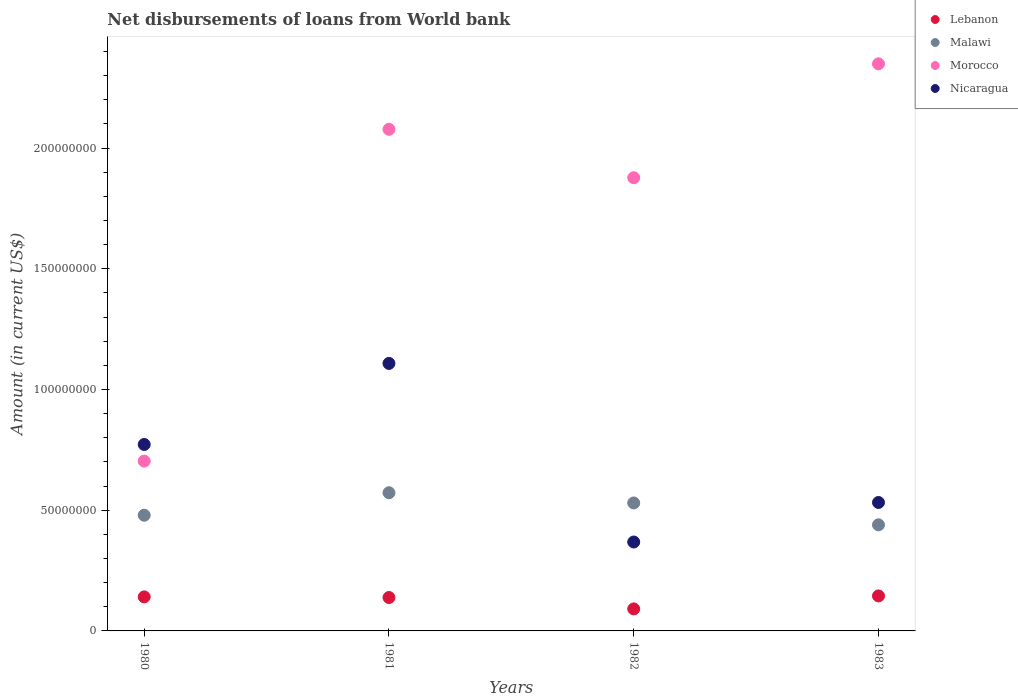How many different coloured dotlines are there?
Your response must be concise. 4. Is the number of dotlines equal to the number of legend labels?
Offer a terse response. Yes. What is the amount of loan disbursed from World Bank in Morocco in 1982?
Ensure brevity in your answer.  1.88e+08. Across all years, what is the maximum amount of loan disbursed from World Bank in Nicaragua?
Your response must be concise. 1.11e+08. Across all years, what is the minimum amount of loan disbursed from World Bank in Nicaragua?
Provide a succinct answer. 3.68e+07. In which year was the amount of loan disbursed from World Bank in Lebanon minimum?
Offer a terse response. 1982. What is the total amount of loan disbursed from World Bank in Morocco in the graph?
Give a very brief answer. 7.01e+08. What is the difference between the amount of loan disbursed from World Bank in Nicaragua in 1980 and that in 1982?
Offer a very short reply. 4.04e+07. What is the difference between the amount of loan disbursed from World Bank in Nicaragua in 1980 and the amount of loan disbursed from World Bank in Lebanon in 1982?
Give a very brief answer. 6.81e+07. What is the average amount of loan disbursed from World Bank in Malawi per year?
Make the answer very short. 5.05e+07. In the year 1983, what is the difference between the amount of loan disbursed from World Bank in Nicaragua and amount of loan disbursed from World Bank in Morocco?
Provide a succinct answer. -1.82e+08. In how many years, is the amount of loan disbursed from World Bank in Lebanon greater than 10000000 US$?
Provide a short and direct response. 3. What is the ratio of the amount of loan disbursed from World Bank in Nicaragua in 1982 to that in 1983?
Offer a very short reply. 0.69. Is the amount of loan disbursed from World Bank in Malawi in 1980 less than that in 1983?
Make the answer very short. No. What is the difference between the highest and the second highest amount of loan disbursed from World Bank in Nicaragua?
Keep it short and to the point. 3.36e+07. What is the difference between the highest and the lowest amount of loan disbursed from World Bank in Malawi?
Your response must be concise. 1.33e+07. Is the sum of the amount of loan disbursed from World Bank in Nicaragua in 1981 and 1982 greater than the maximum amount of loan disbursed from World Bank in Morocco across all years?
Provide a succinct answer. No. Does the amount of loan disbursed from World Bank in Nicaragua monotonically increase over the years?
Your response must be concise. No. Is the amount of loan disbursed from World Bank in Malawi strictly less than the amount of loan disbursed from World Bank in Nicaragua over the years?
Ensure brevity in your answer.  No. How many years are there in the graph?
Make the answer very short. 4. What is the difference between two consecutive major ticks on the Y-axis?
Give a very brief answer. 5.00e+07. Does the graph contain grids?
Your response must be concise. No. How are the legend labels stacked?
Make the answer very short. Vertical. What is the title of the graph?
Give a very brief answer. Net disbursements of loans from World bank. Does "South Africa" appear as one of the legend labels in the graph?
Give a very brief answer. No. What is the Amount (in current US$) of Lebanon in 1980?
Your answer should be compact. 1.41e+07. What is the Amount (in current US$) of Malawi in 1980?
Provide a short and direct response. 4.79e+07. What is the Amount (in current US$) of Morocco in 1980?
Make the answer very short. 7.03e+07. What is the Amount (in current US$) of Nicaragua in 1980?
Ensure brevity in your answer.  7.72e+07. What is the Amount (in current US$) of Lebanon in 1981?
Give a very brief answer. 1.38e+07. What is the Amount (in current US$) of Malawi in 1981?
Provide a short and direct response. 5.72e+07. What is the Amount (in current US$) of Morocco in 1981?
Provide a short and direct response. 2.08e+08. What is the Amount (in current US$) of Nicaragua in 1981?
Your answer should be compact. 1.11e+08. What is the Amount (in current US$) in Lebanon in 1982?
Your response must be concise. 9.12e+06. What is the Amount (in current US$) of Malawi in 1982?
Offer a very short reply. 5.30e+07. What is the Amount (in current US$) of Morocco in 1982?
Your response must be concise. 1.88e+08. What is the Amount (in current US$) in Nicaragua in 1982?
Keep it short and to the point. 3.68e+07. What is the Amount (in current US$) in Lebanon in 1983?
Provide a succinct answer. 1.45e+07. What is the Amount (in current US$) of Malawi in 1983?
Offer a very short reply. 4.40e+07. What is the Amount (in current US$) of Morocco in 1983?
Your response must be concise. 2.35e+08. What is the Amount (in current US$) of Nicaragua in 1983?
Make the answer very short. 5.32e+07. Across all years, what is the maximum Amount (in current US$) of Lebanon?
Your answer should be very brief. 1.45e+07. Across all years, what is the maximum Amount (in current US$) in Malawi?
Provide a short and direct response. 5.72e+07. Across all years, what is the maximum Amount (in current US$) of Morocco?
Your answer should be compact. 2.35e+08. Across all years, what is the maximum Amount (in current US$) in Nicaragua?
Your answer should be very brief. 1.11e+08. Across all years, what is the minimum Amount (in current US$) in Lebanon?
Your answer should be very brief. 9.12e+06. Across all years, what is the minimum Amount (in current US$) of Malawi?
Your answer should be very brief. 4.40e+07. Across all years, what is the minimum Amount (in current US$) of Morocco?
Your answer should be compact. 7.03e+07. Across all years, what is the minimum Amount (in current US$) of Nicaragua?
Provide a short and direct response. 3.68e+07. What is the total Amount (in current US$) in Lebanon in the graph?
Your answer should be compact. 5.16e+07. What is the total Amount (in current US$) of Malawi in the graph?
Provide a succinct answer. 2.02e+08. What is the total Amount (in current US$) of Morocco in the graph?
Provide a short and direct response. 7.01e+08. What is the total Amount (in current US$) in Nicaragua in the graph?
Ensure brevity in your answer.  2.78e+08. What is the difference between the Amount (in current US$) of Lebanon in 1980 and that in 1981?
Offer a terse response. 2.55e+05. What is the difference between the Amount (in current US$) in Malawi in 1980 and that in 1981?
Offer a very short reply. -9.32e+06. What is the difference between the Amount (in current US$) in Morocco in 1980 and that in 1981?
Offer a very short reply. -1.37e+08. What is the difference between the Amount (in current US$) in Nicaragua in 1980 and that in 1981?
Ensure brevity in your answer.  -3.36e+07. What is the difference between the Amount (in current US$) of Lebanon in 1980 and that in 1982?
Offer a very short reply. 4.98e+06. What is the difference between the Amount (in current US$) of Malawi in 1980 and that in 1982?
Give a very brief answer. -5.09e+06. What is the difference between the Amount (in current US$) in Morocco in 1980 and that in 1982?
Your answer should be very brief. -1.17e+08. What is the difference between the Amount (in current US$) of Nicaragua in 1980 and that in 1982?
Keep it short and to the point. 4.04e+07. What is the difference between the Amount (in current US$) of Lebanon in 1980 and that in 1983?
Keep it short and to the point. -4.09e+05. What is the difference between the Amount (in current US$) of Malawi in 1980 and that in 1983?
Give a very brief answer. 3.97e+06. What is the difference between the Amount (in current US$) in Morocco in 1980 and that in 1983?
Your answer should be very brief. -1.65e+08. What is the difference between the Amount (in current US$) of Nicaragua in 1980 and that in 1983?
Your answer should be compact. 2.40e+07. What is the difference between the Amount (in current US$) of Lebanon in 1981 and that in 1982?
Make the answer very short. 4.72e+06. What is the difference between the Amount (in current US$) in Malawi in 1981 and that in 1982?
Your answer should be compact. 4.23e+06. What is the difference between the Amount (in current US$) in Morocco in 1981 and that in 1982?
Your response must be concise. 2.01e+07. What is the difference between the Amount (in current US$) of Nicaragua in 1981 and that in 1982?
Provide a succinct answer. 7.40e+07. What is the difference between the Amount (in current US$) in Lebanon in 1981 and that in 1983?
Your answer should be compact. -6.64e+05. What is the difference between the Amount (in current US$) of Malawi in 1981 and that in 1983?
Your response must be concise. 1.33e+07. What is the difference between the Amount (in current US$) in Morocco in 1981 and that in 1983?
Offer a terse response. -2.71e+07. What is the difference between the Amount (in current US$) of Nicaragua in 1981 and that in 1983?
Offer a terse response. 5.76e+07. What is the difference between the Amount (in current US$) in Lebanon in 1982 and that in 1983?
Offer a very short reply. -5.38e+06. What is the difference between the Amount (in current US$) of Malawi in 1982 and that in 1983?
Offer a terse response. 9.06e+06. What is the difference between the Amount (in current US$) of Morocco in 1982 and that in 1983?
Provide a succinct answer. -4.72e+07. What is the difference between the Amount (in current US$) in Nicaragua in 1982 and that in 1983?
Ensure brevity in your answer.  -1.64e+07. What is the difference between the Amount (in current US$) of Lebanon in 1980 and the Amount (in current US$) of Malawi in 1981?
Provide a succinct answer. -4.31e+07. What is the difference between the Amount (in current US$) of Lebanon in 1980 and the Amount (in current US$) of Morocco in 1981?
Your answer should be compact. -1.94e+08. What is the difference between the Amount (in current US$) in Lebanon in 1980 and the Amount (in current US$) in Nicaragua in 1981?
Make the answer very short. -9.67e+07. What is the difference between the Amount (in current US$) of Malawi in 1980 and the Amount (in current US$) of Morocco in 1981?
Ensure brevity in your answer.  -1.60e+08. What is the difference between the Amount (in current US$) of Malawi in 1980 and the Amount (in current US$) of Nicaragua in 1981?
Offer a very short reply. -6.29e+07. What is the difference between the Amount (in current US$) of Morocco in 1980 and the Amount (in current US$) of Nicaragua in 1981?
Ensure brevity in your answer.  -4.05e+07. What is the difference between the Amount (in current US$) in Lebanon in 1980 and the Amount (in current US$) in Malawi in 1982?
Your answer should be very brief. -3.89e+07. What is the difference between the Amount (in current US$) in Lebanon in 1980 and the Amount (in current US$) in Morocco in 1982?
Keep it short and to the point. -1.74e+08. What is the difference between the Amount (in current US$) in Lebanon in 1980 and the Amount (in current US$) in Nicaragua in 1982?
Keep it short and to the point. -2.27e+07. What is the difference between the Amount (in current US$) in Malawi in 1980 and the Amount (in current US$) in Morocco in 1982?
Your answer should be compact. -1.40e+08. What is the difference between the Amount (in current US$) of Malawi in 1980 and the Amount (in current US$) of Nicaragua in 1982?
Make the answer very short. 1.11e+07. What is the difference between the Amount (in current US$) in Morocco in 1980 and the Amount (in current US$) in Nicaragua in 1982?
Offer a very short reply. 3.35e+07. What is the difference between the Amount (in current US$) of Lebanon in 1980 and the Amount (in current US$) of Malawi in 1983?
Ensure brevity in your answer.  -2.99e+07. What is the difference between the Amount (in current US$) in Lebanon in 1980 and the Amount (in current US$) in Morocco in 1983?
Provide a short and direct response. -2.21e+08. What is the difference between the Amount (in current US$) in Lebanon in 1980 and the Amount (in current US$) in Nicaragua in 1983?
Make the answer very short. -3.91e+07. What is the difference between the Amount (in current US$) in Malawi in 1980 and the Amount (in current US$) in Morocco in 1983?
Offer a terse response. -1.87e+08. What is the difference between the Amount (in current US$) of Malawi in 1980 and the Amount (in current US$) of Nicaragua in 1983?
Give a very brief answer. -5.28e+06. What is the difference between the Amount (in current US$) of Morocco in 1980 and the Amount (in current US$) of Nicaragua in 1983?
Provide a succinct answer. 1.71e+07. What is the difference between the Amount (in current US$) in Lebanon in 1981 and the Amount (in current US$) in Malawi in 1982?
Your answer should be compact. -3.92e+07. What is the difference between the Amount (in current US$) in Lebanon in 1981 and the Amount (in current US$) in Morocco in 1982?
Your answer should be compact. -1.74e+08. What is the difference between the Amount (in current US$) in Lebanon in 1981 and the Amount (in current US$) in Nicaragua in 1982?
Your answer should be compact. -2.30e+07. What is the difference between the Amount (in current US$) of Malawi in 1981 and the Amount (in current US$) of Morocco in 1982?
Make the answer very short. -1.30e+08. What is the difference between the Amount (in current US$) of Malawi in 1981 and the Amount (in current US$) of Nicaragua in 1982?
Keep it short and to the point. 2.04e+07. What is the difference between the Amount (in current US$) in Morocco in 1981 and the Amount (in current US$) in Nicaragua in 1982?
Provide a succinct answer. 1.71e+08. What is the difference between the Amount (in current US$) of Lebanon in 1981 and the Amount (in current US$) of Malawi in 1983?
Keep it short and to the point. -3.01e+07. What is the difference between the Amount (in current US$) of Lebanon in 1981 and the Amount (in current US$) of Morocco in 1983?
Provide a short and direct response. -2.21e+08. What is the difference between the Amount (in current US$) of Lebanon in 1981 and the Amount (in current US$) of Nicaragua in 1983?
Keep it short and to the point. -3.94e+07. What is the difference between the Amount (in current US$) in Malawi in 1981 and the Amount (in current US$) in Morocco in 1983?
Ensure brevity in your answer.  -1.78e+08. What is the difference between the Amount (in current US$) of Malawi in 1981 and the Amount (in current US$) of Nicaragua in 1983?
Your response must be concise. 4.04e+06. What is the difference between the Amount (in current US$) in Morocco in 1981 and the Amount (in current US$) in Nicaragua in 1983?
Your answer should be compact. 1.55e+08. What is the difference between the Amount (in current US$) in Lebanon in 1982 and the Amount (in current US$) in Malawi in 1983?
Keep it short and to the point. -3.48e+07. What is the difference between the Amount (in current US$) of Lebanon in 1982 and the Amount (in current US$) of Morocco in 1983?
Provide a succinct answer. -2.26e+08. What is the difference between the Amount (in current US$) of Lebanon in 1982 and the Amount (in current US$) of Nicaragua in 1983?
Give a very brief answer. -4.41e+07. What is the difference between the Amount (in current US$) of Malawi in 1982 and the Amount (in current US$) of Morocco in 1983?
Provide a short and direct response. -1.82e+08. What is the difference between the Amount (in current US$) in Morocco in 1982 and the Amount (in current US$) in Nicaragua in 1983?
Keep it short and to the point. 1.35e+08. What is the average Amount (in current US$) of Lebanon per year?
Offer a terse response. 1.29e+07. What is the average Amount (in current US$) of Malawi per year?
Your response must be concise. 5.05e+07. What is the average Amount (in current US$) of Morocco per year?
Provide a short and direct response. 1.75e+08. What is the average Amount (in current US$) in Nicaragua per year?
Provide a succinct answer. 6.95e+07. In the year 1980, what is the difference between the Amount (in current US$) of Lebanon and Amount (in current US$) of Malawi?
Your answer should be compact. -3.38e+07. In the year 1980, what is the difference between the Amount (in current US$) of Lebanon and Amount (in current US$) of Morocco?
Make the answer very short. -5.63e+07. In the year 1980, what is the difference between the Amount (in current US$) of Lebanon and Amount (in current US$) of Nicaragua?
Your answer should be compact. -6.31e+07. In the year 1980, what is the difference between the Amount (in current US$) in Malawi and Amount (in current US$) in Morocco?
Keep it short and to the point. -2.24e+07. In the year 1980, what is the difference between the Amount (in current US$) in Malawi and Amount (in current US$) in Nicaragua?
Your answer should be compact. -2.93e+07. In the year 1980, what is the difference between the Amount (in current US$) in Morocco and Amount (in current US$) in Nicaragua?
Your answer should be compact. -6.89e+06. In the year 1981, what is the difference between the Amount (in current US$) of Lebanon and Amount (in current US$) of Malawi?
Make the answer very short. -4.34e+07. In the year 1981, what is the difference between the Amount (in current US$) of Lebanon and Amount (in current US$) of Morocco?
Make the answer very short. -1.94e+08. In the year 1981, what is the difference between the Amount (in current US$) of Lebanon and Amount (in current US$) of Nicaragua?
Offer a terse response. -9.70e+07. In the year 1981, what is the difference between the Amount (in current US$) in Malawi and Amount (in current US$) in Morocco?
Your answer should be very brief. -1.51e+08. In the year 1981, what is the difference between the Amount (in current US$) of Malawi and Amount (in current US$) of Nicaragua?
Your answer should be compact. -5.36e+07. In the year 1981, what is the difference between the Amount (in current US$) of Morocco and Amount (in current US$) of Nicaragua?
Provide a succinct answer. 9.70e+07. In the year 1982, what is the difference between the Amount (in current US$) in Lebanon and Amount (in current US$) in Malawi?
Offer a terse response. -4.39e+07. In the year 1982, what is the difference between the Amount (in current US$) in Lebanon and Amount (in current US$) in Morocco?
Make the answer very short. -1.79e+08. In the year 1982, what is the difference between the Amount (in current US$) of Lebanon and Amount (in current US$) of Nicaragua?
Make the answer very short. -2.77e+07. In the year 1982, what is the difference between the Amount (in current US$) of Malawi and Amount (in current US$) of Morocco?
Your answer should be compact. -1.35e+08. In the year 1982, what is the difference between the Amount (in current US$) of Malawi and Amount (in current US$) of Nicaragua?
Your response must be concise. 1.62e+07. In the year 1982, what is the difference between the Amount (in current US$) of Morocco and Amount (in current US$) of Nicaragua?
Your answer should be compact. 1.51e+08. In the year 1983, what is the difference between the Amount (in current US$) of Lebanon and Amount (in current US$) of Malawi?
Provide a succinct answer. -2.94e+07. In the year 1983, what is the difference between the Amount (in current US$) in Lebanon and Amount (in current US$) in Morocco?
Your response must be concise. -2.20e+08. In the year 1983, what is the difference between the Amount (in current US$) of Lebanon and Amount (in current US$) of Nicaragua?
Offer a terse response. -3.87e+07. In the year 1983, what is the difference between the Amount (in current US$) of Malawi and Amount (in current US$) of Morocco?
Make the answer very short. -1.91e+08. In the year 1983, what is the difference between the Amount (in current US$) of Malawi and Amount (in current US$) of Nicaragua?
Keep it short and to the point. -9.25e+06. In the year 1983, what is the difference between the Amount (in current US$) in Morocco and Amount (in current US$) in Nicaragua?
Your answer should be very brief. 1.82e+08. What is the ratio of the Amount (in current US$) of Lebanon in 1980 to that in 1981?
Your answer should be very brief. 1.02. What is the ratio of the Amount (in current US$) of Malawi in 1980 to that in 1981?
Make the answer very short. 0.84. What is the ratio of the Amount (in current US$) of Morocco in 1980 to that in 1981?
Provide a succinct answer. 0.34. What is the ratio of the Amount (in current US$) in Nicaragua in 1980 to that in 1981?
Make the answer very short. 0.7. What is the ratio of the Amount (in current US$) of Lebanon in 1980 to that in 1982?
Give a very brief answer. 1.55. What is the ratio of the Amount (in current US$) of Malawi in 1980 to that in 1982?
Make the answer very short. 0.9. What is the ratio of the Amount (in current US$) in Morocco in 1980 to that in 1982?
Ensure brevity in your answer.  0.37. What is the ratio of the Amount (in current US$) in Nicaragua in 1980 to that in 1982?
Provide a short and direct response. 2.1. What is the ratio of the Amount (in current US$) in Lebanon in 1980 to that in 1983?
Offer a terse response. 0.97. What is the ratio of the Amount (in current US$) of Malawi in 1980 to that in 1983?
Make the answer very short. 1.09. What is the ratio of the Amount (in current US$) in Morocco in 1980 to that in 1983?
Offer a terse response. 0.3. What is the ratio of the Amount (in current US$) in Nicaragua in 1980 to that in 1983?
Provide a short and direct response. 1.45. What is the ratio of the Amount (in current US$) of Lebanon in 1981 to that in 1982?
Your answer should be very brief. 1.52. What is the ratio of the Amount (in current US$) in Malawi in 1981 to that in 1982?
Offer a terse response. 1.08. What is the ratio of the Amount (in current US$) of Morocco in 1981 to that in 1982?
Provide a succinct answer. 1.11. What is the ratio of the Amount (in current US$) in Nicaragua in 1981 to that in 1982?
Your response must be concise. 3.01. What is the ratio of the Amount (in current US$) in Lebanon in 1981 to that in 1983?
Offer a terse response. 0.95. What is the ratio of the Amount (in current US$) of Malawi in 1981 to that in 1983?
Make the answer very short. 1.3. What is the ratio of the Amount (in current US$) in Morocco in 1981 to that in 1983?
Your answer should be very brief. 0.88. What is the ratio of the Amount (in current US$) of Nicaragua in 1981 to that in 1983?
Your answer should be compact. 2.08. What is the ratio of the Amount (in current US$) in Lebanon in 1982 to that in 1983?
Ensure brevity in your answer.  0.63. What is the ratio of the Amount (in current US$) in Malawi in 1982 to that in 1983?
Offer a terse response. 1.21. What is the ratio of the Amount (in current US$) of Morocco in 1982 to that in 1983?
Keep it short and to the point. 0.8. What is the ratio of the Amount (in current US$) of Nicaragua in 1982 to that in 1983?
Provide a succinct answer. 0.69. What is the difference between the highest and the second highest Amount (in current US$) in Lebanon?
Provide a short and direct response. 4.09e+05. What is the difference between the highest and the second highest Amount (in current US$) in Malawi?
Provide a short and direct response. 4.23e+06. What is the difference between the highest and the second highest Amount (in current US$) of Morocco?
Give a very brief answer. 2.71e+07. What is the difference between the highest and the second highest Amount (in current US$) in Nicaragua?
Give a very brief answer. 3.36e+07. What is the difference between the highest and the lowest Amount (in current US$) of Lebanon?
Your answer should be compact. 5.38e+06. What is the difference between the highest and the lowest Amount (in current US$) in Malawi?
Give a very brief answer. 1.33e+07. What is the difference between the highest and the lowest Amount (in current US$) of Morocco?
Offer a terse response. 1.65e+08. What is the difference between the highest and the lowest Amount (in current US$) of Nicaragua?
Keep it short and to the point. 7.40e+07. 